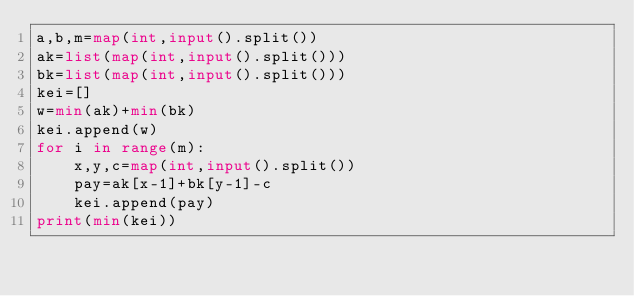Convert code to text. <code><loc_0><loc_0><loc_500><loc_500><_Python_>a,b,m=map(int,input().split())
ak=list(map(int,input().split()))
bk=list(map(int,input().split()))
kei=[]
w=min(ak)+min(bk)
kei.append(w)
for i in range(m):
    x,y,c=map(int,input().split())
    pay=ak[x-1]+bk[y-1]-c
    kei.append(pay)
print(min(kei))
</code> 